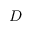Convert formula to latex. <formula><loc_0><loc_0><loc_500><loc_500>D</formula> 